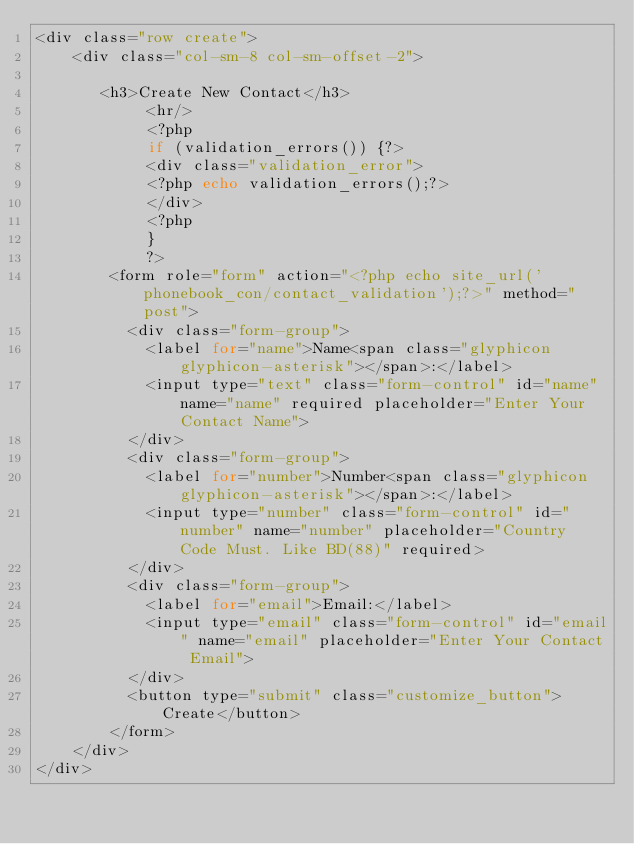Convert code to text. <code><loc_0><loc_0><loc_500><loc_500><_PHP_><div class="row create">
	<div class="col-sm-8 col-sm-offset-2">
	   
	   <h3>Create New Contact</h3>
	        <hr/>
	        <?php
			if (validation_errors()) {?>
			<div class="validation_error"> 
			<?php echo validation_errors();?>
			</div>
			<?php  
			}
			?>
		<form role="form" action="<?php echo site_url('phonebook_con/contact_validation');?>" method="post">
		  <div class="form-group">
		    <label for="name">Name<span class="glyphicon glyphicon-asterisk"></span>:</label>
		    <input type="text" class="form-control" id="name" name="name" required placeholder="Enter Your Contact Name">
		  </div>
		  <div class="form-group">
		    <label for="number">Number<span class="glyphicon glyphicon-asterisk"></span>:</label>
		    <input type="number" class="form-control" id="number" name="number" placeholder="Country Code Must. Like BD(88)" required>
		  </div>
		  <div class="form-group">
		    <label for="email">Email:</label>
		    <input type="email" class="form-control" id="email" name="email" placeholder="Enter Your Contact Email">
		  </div>
		  <button type="submit" class="customize_button">Create</button>
        </form> 
	</div>
</div> </code> 